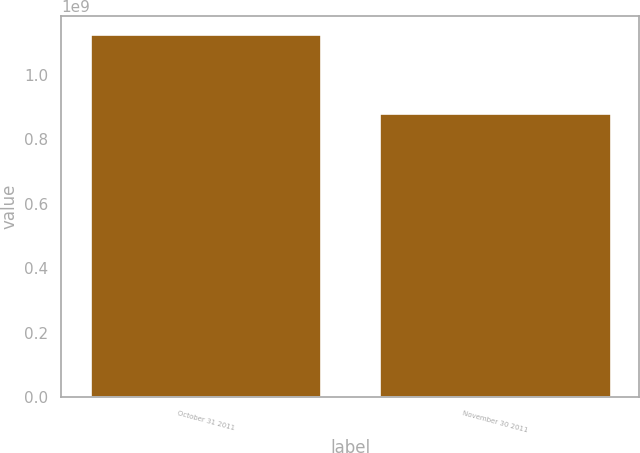Convert chart. <chart><loc_0><loc_0><loc_500><loc_500><bar_chart><fcel>October 31 2011<fcel>November 30 2011<nl><fcel>1.12659e+09<fcel>8.80522e+08<nl></chart> 